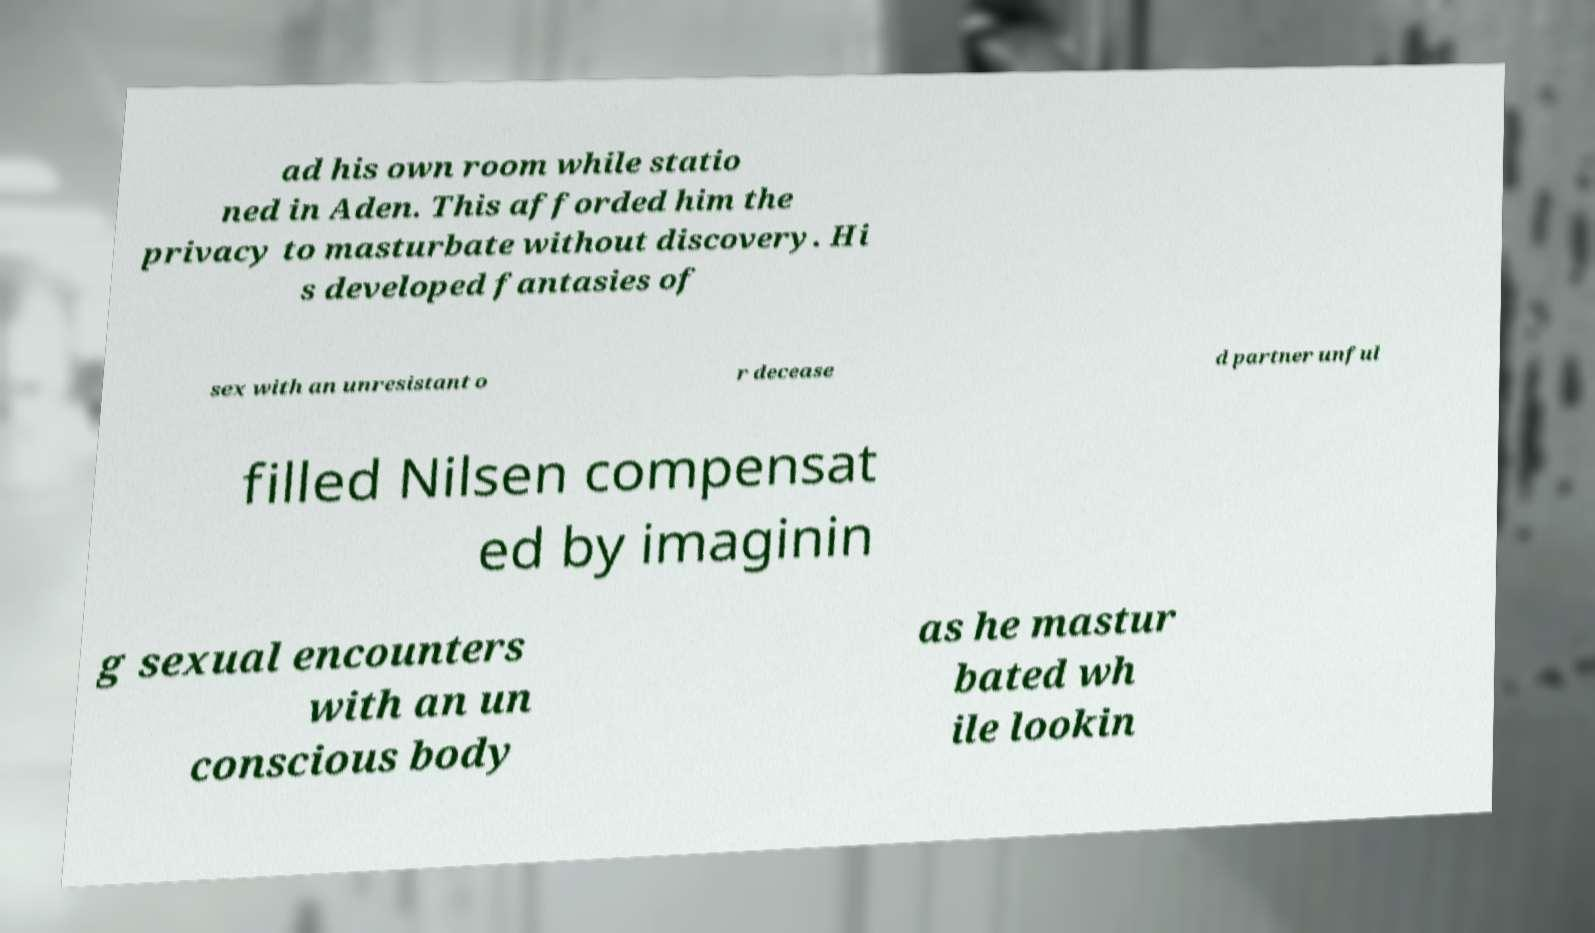Could you assist in decoding the text presented in this image and type it out clearly? ad his own room while statio ned in Aden. This afforded him the privacy to masturbate without discovery. Hi s developed fantasies of sex with an unresistant o r decease d partner unful filled Nilsen compensat ed by imaginin g sexual encounters with an un conscious body as he mastur bated wh ile lookin 